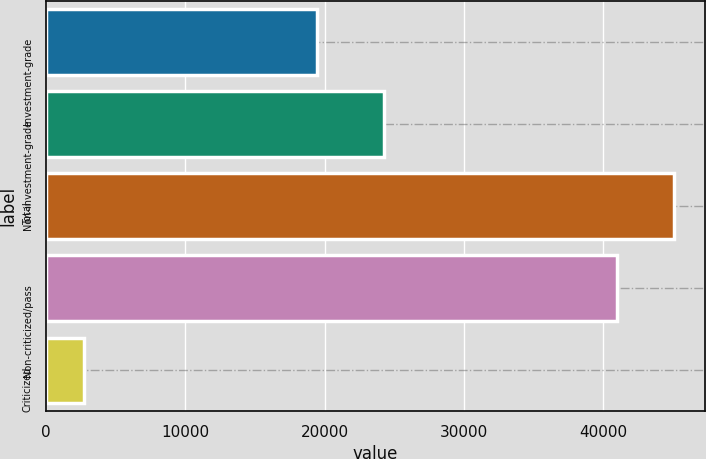Convert chart. <chart><loc_0><loc_0><loc_500><loc_500><bar_chart><fcel>Investment-grade<fcel>Non-investment-grade<fcel>Total<fcel>Non-criticized/pass<fcel>Criticized<nl><fcel>19459<fcel>24241<fcel>45063.7<fcel>40967<fcel>2733<nl></chart> 